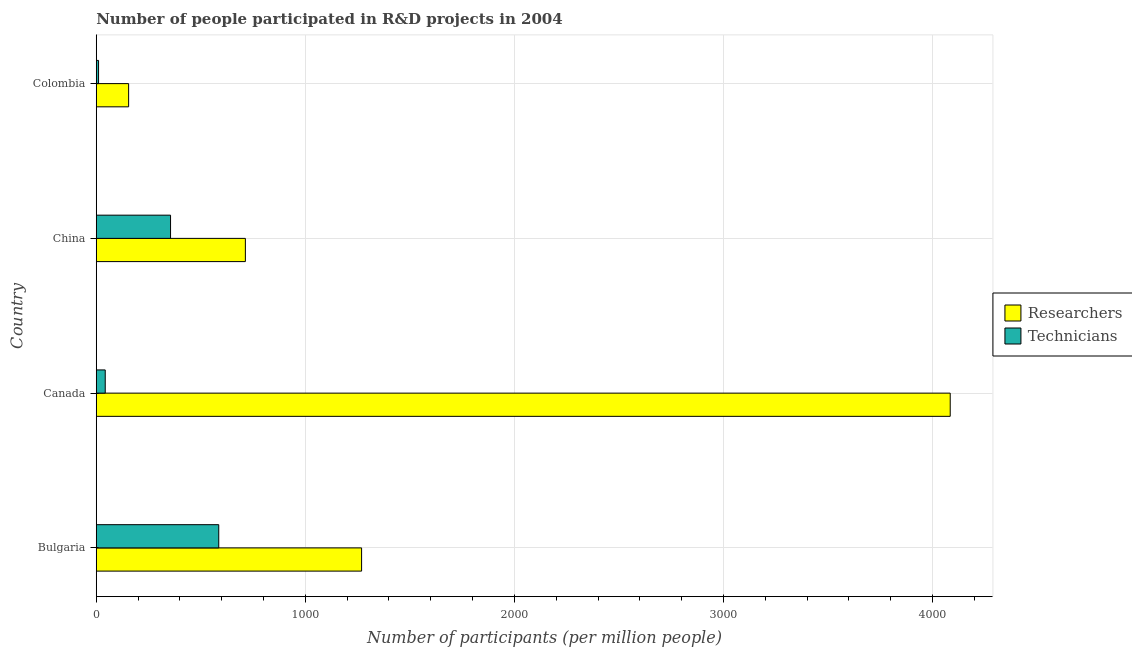How many different coloured bars are there?
Your answer should be very brief. 2. How many groups of bars are there?
Provide a succinct answer. 4. Are the number of bars per tick equal to the number of legend labels?
Provide a succinct answer. Yes. Are the number of bars on each tick of the Y-axis equal?
Offer a terse response. Yes. What is the label of the 3rd group of bars from the top?
Ensure brevity in your answer.  Canada. What is the number of researchers in China?
Provide a succinct answer. 713.28. Across all countries, what is the maximum number of technicians?
Offer a very short reply. 585.92. Across all countries, what is the minimum number of researchers?
Ensure brevity in your answer.  154.82. In which country was the number of researchers minimum?
Ensure brevity in your answer.  Colombia. What is the total number of researchers in the graph?
Ensure brevity in your answer.  6222.06. What is the difference between the number of researchers in Bulgaria and that in Colombia?
Ensure brevity in your answer.  1114.37. What is the difference between the number of researchers in Bulgaria and the number of technicians in Canada?
Keep it short and to the point. 1226.26. What is the average number of technicians per country?
Your answer should be compact. 248.8. What is the difference between the number of researchers and number of technicians in Colombia?
Offer a very short reply. 143.83. What is the ratio of the number of technicians in Canada to that in Colombia?
Offer a very short reply. 3.91. Is the number of technicians in Bulgaria less than that in China?
Your answer should be compact. No. What is the difference between the highest and the second highest number of researchers?
Your response must be concise. 2815.58. What is the difference between the highest and the lowest number of researchers?
Give a very brief answer. 3929.95. In how many countries, is the number of technicians greater than the average number of technicians taken over all countries?
Provide a short and direct response. 2. Is the sum of the number of researchers in Canada and China greater than the maximum number of technicians across all countries?
Give a very brief answer. Yes. What does the 1st bar from the top in Bulgaria represents?
Your answer should be very brief. Technicians. What does the 1st bar from the bottom in Colombia represents?
Your response must be concise. Researchers. Are all the bars in the graph horizontal?
Offer a very short reply. Yes. Are the values on the major ticks of X-axis written in scientific E-notation?
Provide a succinct answer. No. Does the graph contain grids?
Give a very brief answer. Yes. Where does the legend appear in the graph?
Your answer should be very brief. Center right. How are the legend labels stacked?
Provide a short and direct response. Vertical. What is the title of the graph?
Your response must be concise. Number of people participated in R&D projects in 2004. Does "Domestic Liabilities" appear as one of the legend labels in the graph?
Your answer should be compact. No. What is the label or title of the X-axis?
Make the answer very short. Number of participants (per million people). What is the Number of participants (per million people) of Researchers in Bulgaria?
Give a very brief answer. 1269.19. What is the Number of participants (per million people) of Technicians in Bulgaria?
Provide a succinct answer. 585.92. What is the Number of participants (per million people) of Researchers in Canada?
Ensure brevity in your answer.  4084.77. What is the Number of participants (per million people) of Technicians in Canada?
Offer a very short reply. 42.93. What is the Number of participants (per million people) of Researchers in China?
Provide a short and direct response. 713.28. What is the Number of participants (per million people) of Technicians in China?
Make the answer very short. 355.35. What is the Number of participants (per million people) of Researchers in Colombia?
Give a very brief answer. 154.82. What is the Number of participants (per million people) of Technicians in Colombia?
Your answer should be very brief. 10.98. Across all countries, what is the maximum Number of participants (per million people) in Researchers?
Your response must be concise. 4084.77. Across all countries, what is the maximum Number of participants (per million people) of Technicians?
Provide a succinct answer. 585.92. Across all countries, what is the minimum Number of participants (per million people) in Researchers?
Ensure brevity in your answer.  154.82. Across all countries, what is the minimum Number of participants (per million people) of Technicians?
Offer a very short reply. 10.98. What is the total Number of participants (per million people) in Researchers in the graph?
Keep it short and to the point. 6222.06. What is the total Number of participants (per million people) in Technicians in the graph?
Offer a terse response. 995.19. What is the difference between the Number of participants (per million people) in Researchers in Bulgaria and that in Canada?
Provide a short and direct response. -2815.58. What is the difference between the Number of participants (per million people) in Technicians in Bulgaria and that in Canada?
Provide a succinct answer. 542.99. What is the difference between the Number of participants (per million people) of Researchers in Bulgaria and that in China?
Offer a terse response. 555.9. What is the difference between the Number of participants (per million people) in Technicians in Bulgaria and that in China?
Make the answer very short. 230.58. What is the difference between the Number of participants (per million people) in Researchers in Bulgaria and that in Colombia?
Ensure brevity in your answer.  1114.37. What is the difference between the Number of participants (per million people) in Technicians in Bulgaria and that in Colombia?
Give a very brief answer. 574.94. What is the difference between the Number of participants (per million people) in Researchers in Canada and that in China?
Your answer should be compact. 3371.48. What is the difference between the Number of participants (per million people) of Technicians in Canada and that in China?
Provide a succinct answer. -312.42. What is the difference between the Number of participants (per million people) in Researchers in Canada and that in Colombia?
Provide a succinct answer. 3929.95. What is the difference between the Number of participants (per million people) in Technicians in Canada and that in Colombia?
Your response must be concise. 31.95. What is the difference between the Number of participants (per million people) in Researchers in China and that in Colombia?
Offer a very short reply. 558.47. What is the difference between the Number of participants (per million people) in Technicians in China and that in Colombia?
Give a very brief answer. 344.37. What is the difference between the Number of participants (per million people) of Researchers in Bulgaria and the Number of participants (per million people) of Technicians in Canada?
Give a very brief answer. 1226.26. What is the difference between the Number of participants (per million people) of Researchers in Bulgaria and the Number of participants (per million people) of Technicians in China?
Your answer should be very brief. 913.84. What is the difference between the Number of participants (per million people) of Researchers in Bulgaria and the Number of participants (per million people) of Technicians in Colombia?
Provide a succinct answer. 1258.21. What is the difference between the Number of participants (per million people) in Researchers in Canada and the Number of participants (per million people) in Technicians in China?
Your response must be concise. 3729.42. What is the difference between the Number of participants (per million people) of Researchers in Canada and the Number of participants (per million people) of Technicians in Colombia?
Ensure brevity in your answer.  4073.78. What is the difference between the Number of participants (per million people) of Researchers in China and the Number of participants (per million people) of Technicians in Colombia?
Provide a succinct answer. 702.3. What is the average Number of participants (per million people) of Researchers per country?
Your answer should be very brief. 1555.51. What is the average Number of participants (per million people) in Technicians per country?
Give a very brief answer. 248.8. What is the difference between the Number of participants (per million people) of Researchers and Number of participants (per million people) of Technicians in Bulgaria?
Provide a succinct answer. 683.26. What is the difference between the Number of participants (per million people) of Researchers and Number of participants (per million people) of Technicians in Canada?
Keep it short and to the point. 4041.84. What is the difference between the Number of participants (per million people) in Researchers and Number of participants (per million people) in Technicians in China?
Provide a short and direct response. 357.94. What is the difference between the Number of participants (per million people) in Researchers and Number of participants (per million people) in Technicians in Colombia?
Your response must be concise. 143.83. What is the ratio of the Number of participants (per million people) of Researchers in Bulgaria to that in Canada?
Provide a short and direct response. 0.31. What is the ratio of the Number of participants (per million people) of Technicians in Bulgaria to that in Canada?
Keep it short and to the point. 13.65. What is the ratio of the Number of participants (per million people) of Researchers in Bulgaria to that in China?
Your answer should be compact. 1.78. What is the ratio of the Number of participants (per million people) of Technicians in Bulgaria to that in China?
Your answer should be compact. 1.65. What is the ratio of the Number of participants (per million people) in Researchers in Bulgaria to that in Colombia?
Offer a terse response. 8.2. What is the ratio of the Number of participants (per million people) in Technicians in Bulgaria to that in Colombia?
Your response must be concise. 53.35. What is the ratio of the Number of participants (per million people) of Researchers in Canada to that in China?
Offer a terse response. 5.73. What is the ratio of the Number of participants (per million people) of Technicians in Canada to that in China?
Offer a very short reply. 0.12. What is the ratio of the Number of participants (per million people) in Researchers in Canada to that in Colombia?
Offer a very short reply. 26.38. What is the ratio of the Number of participants (per million people) in Technicians in Canada to that in Colombia?
Your answer should be compact. 3.91. What is the ratio of the Number of participants (per million people) of Researchers in China to that in Colombia?
Ensure brevity in your answer.  4.61. What is the ratio of the Number of participants (per million people) of Technicians in China to that in Colombia?
Your answer should be compact. 32.35. What is the difference between the highest and the second highest Number of participants (per million people) in Researchers?
Offer a very short reply. 2815.58. What is the difference between the highest and the second highest Number of participants (per million people) of Technicians?
Ensure brevity in your answer.  230.58. What is the difference between the highest and the lowest Number of participants (per million people) of Researchers?
Ensure brevity in your answer.  3929.95. What is the difference between the highest and the lowest Number of participants (per million people) in Technicians?
Make the answer very short. 574.94. 